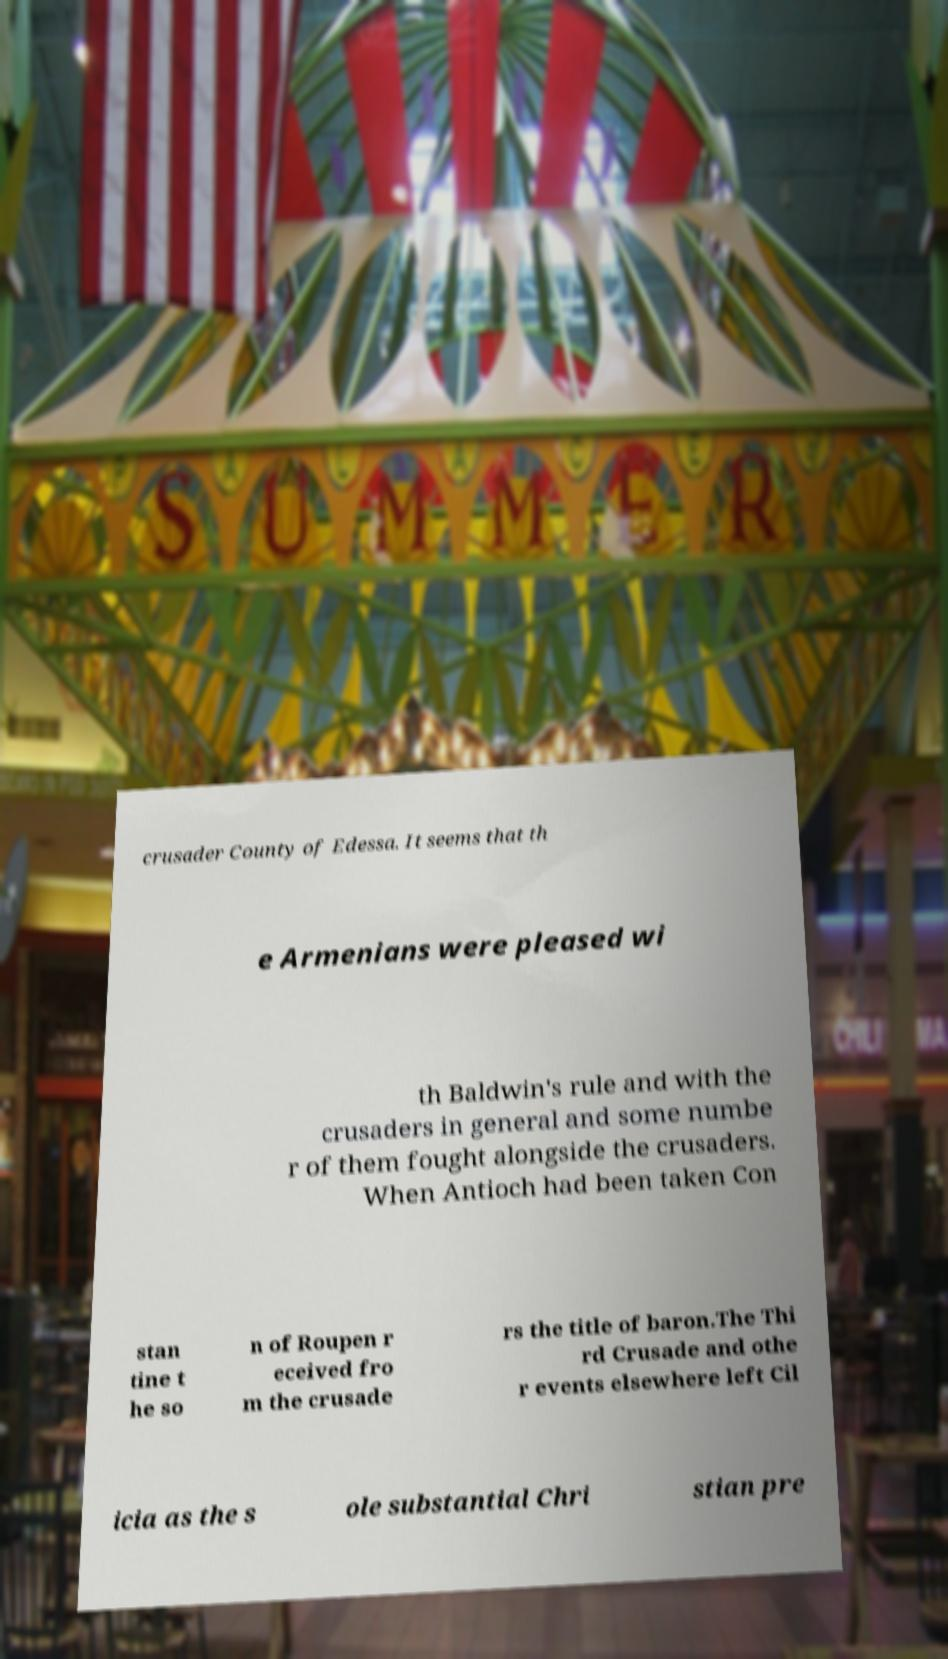Can you accurately transcribe the text from the provided image for me? crusader County of Edessa. It seems that th e Armenians were pleased wi th Baldwin's rule and with the crusaders in general and some numbe r of them fought alongside the crusaders. When Antioch had been taken Con stan tine t he so n of Roupen r eceived fro m the crusade rs the title of baron.The Thi rd Crusade and othe r events elsewhere left Cil icia as the s ole substantial Chri stian pre 